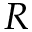Convert formula to latex. <formula><loc_0><loc_0><loc_500><loc_500>R</formula> 